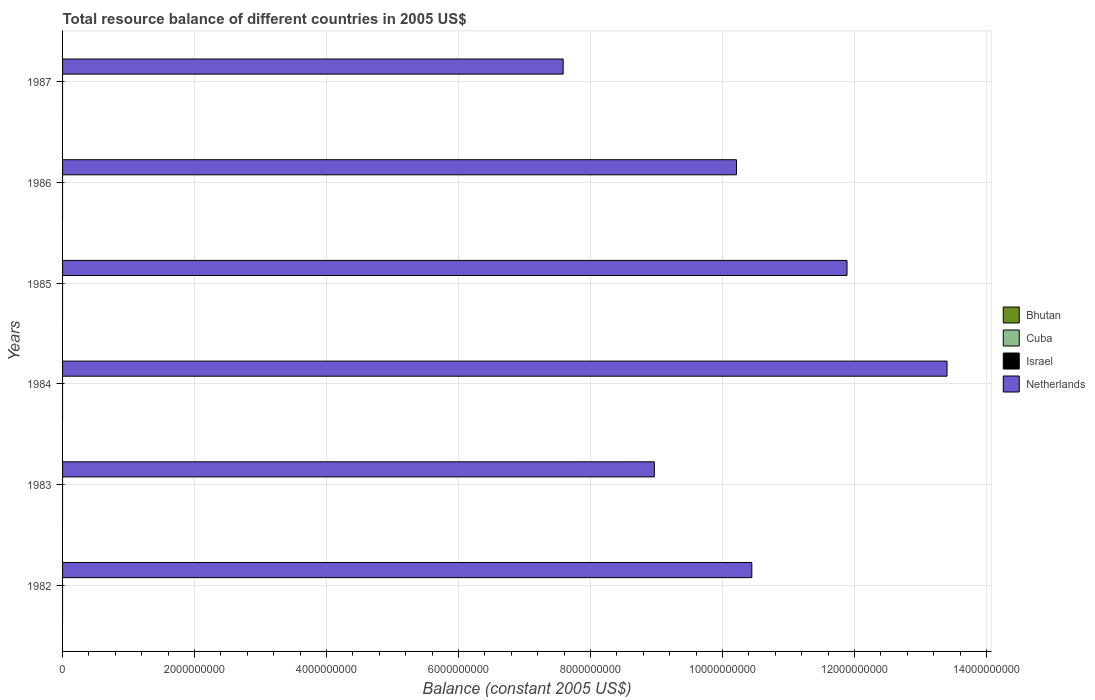Are the number of bars on each tick of the Y-axis equal?
Your answer should be very brief. Yes. What is the label of the 5th group of bars from the top?
Offer a terse response. 1983. In how many cases, is the number of bars for a given year not equal to the number of legend labels?
Your response must be concise. 6. What is the total resource balance in Cuba in 1985?
Your answer should be very brief. 0. Across all years, what is the maximum total resource balance in Netherlands?
Your answer should be very brief. 1.34e+1. Across all years, what is the minimum total resource balance in Israel?
Keep it short and to the point. 0. What is the total total resource balance in Cuba in the graph?
Your answer should be compact. 0. What is the difference between the total resource balance in Netherlands in 1983 and that in 1984?
Ensure brevity in your answer.  -4.44e+09. What is the difference between the total resource balance in Netherlands in 1984 and the total resource balance in Cuba in 1986?
Your response must be concise. 1.34e+1. What is the ratio of the total resource balance in Netherlands in 1984 to that in 1987?
Offer a very short reply. 1.77. Is the total resource balance in Netherlands in 1984 less than that in 1987?
Your answer should be very brief. No. What is the difference between the highest and the second highest total resource balance in Netherlands?
Make the answer very short. 1.52e+09. What is the difference between the highest and the lowest total resource balance in Netherlands?
Ensure brevity in your answer.  5.82e+09. Is it the case that in every year, the sum of the total resource balance in Bhutan and total resource balance in Cuba is greater than the total resource balance in Israel?
Make the answer very short. No. How many bars are there?
Your answer should be compact. 6. Does the graph contain any zero values?
Offer a terse response. Yes. Does the graph contain grids?
Offer a terse response. Yes. How are the legend labels stacked?
Make the answer very short. Vertical. What is the title of the graph?
Ensure brevity in your answer.  Total resource balance of different countries in 2005 US$. Does "Other small states" appear as one of the legend labels in the graph?
Offer a terse response. No. What is the label or title of the X-axis?
Ensure brevity in your answer.  Balance (constant 2005 US$). What is the Balance (constant 2005 US$) in Israel in 1982?
Make the answer very short. 0. What is the Balance (constant 2005 US$) of Netherlands in 1982?
Your answer should be very brief. 1.04e+1. What is the Balance (constant 2005 US$) in Cuba in 1983?
Your answer should be compact. 0. What is the Balance (constant 2005 US$) in Israel in 1983?
Your answer should be very brief. 0. What is the Balance (constant 2005 US$) in Netherlands in 1983?
Your answer should be compact. 8.97e+09. What is the Balance (constant 2005 US$) of Israel in 1984?
Give a very brief answer. 0. What is the Balance (constant 2005 US$) of Netherlands in 1984?
Ensure brevity in your answer.  1.34e+1. What is the Balance (constant 2005 US$) in Bhutan in 1985?
Offer a terse response. 0. What is the Balance (constant 2005 US$) in Cuba in 1985?
Ensure brevity in your answer.  0. What is the Balance (constant 2005 US$) in Israel in 1985?
Give a very brief answer. 0. What is the Balance (constant 2005 US$) in Netherlands in 1985?
Offer a very short reply. 1.19e+1. What is the Balance (constant 2005 US$) in Cuba in 1986?
Keep it short and to the point. 0. What is the Balance (constant 2005 US$) in Netherlands in 1986?
Provide a short and direct response. 1.02e+1. What is the Balance (constant 2005 US$) of Bhutan in 1987?
Offer a terse response. 0. What is the Balance (constant 2005 US$) of Cuba in 1987?
Give a very brief answer. 0. What is the Balance (constant 2005 US$) of Netherlands in 1987?
Make the answer very short. 7.59e+09. Across all years, what is the maximum Balance (constant 2005 US$) of Netherlands?
Your response must be concise. 1.34e+1. Across all years, what is the minimum Balance (constant 2005 US$) in Netherlands?
Keep it short and to the point. 7.59e+09. What is the total Balance (constant 2005 US$) in Israel in the graph?
Provide a succinct answer. 0. What is the total Balance (constant 2005 US$) of Netherlands in the graph?
Your response must be concise. 6.25e+1. What is the difference between the Balance (constant 2005 US$) in Netherlands in 1982 and that in 1983?
Provide a short and direct response. 1.48e+09. What is the difference between the Balance (constant 2005 US$) in Netherlands in 1982 and that in 1984?
Keep it short and to the point. -2.96e+09. What is the difference between the Balance (constant 2005 US$) of Netherlands in 1982 and that in 1985?
Ensure brevity in your answer.  -1.44e+09. What is the difference between the Balance (constant 2005 US$) in Netherlands in 1982 and that in 1986?
Offer a very short reply. 2.32e+08. What is the difference between the Balance (constant 2005 US$) of Netherlands in 1982 and that in 1987?
Give a very brief answer. 2.86e+09. What is the difference between the Balance (constant 2005 US$) of Netherlands in 1983 and that in 1984?
Offer a very short reply. -4.44e+09. What is the difference between the Balance (constant 2005 US$) in Netherlands in 1983 and that in 1985?
Offer a very short reply. -2.92e+09. What is the difference between the Balance (constant 2005 US$) of Netherlands in 1983 and that in 1986?
Provide a succinct answer. -1.24e+09. What is the difference between the Balance (constant 2005 US$) in Netherlands in 1983 and that in 1987?
Provide a short and direct response. 1.38e+09. What is the difference between the Balance (constant 2005 US$) in Netherlands in 1984 and that in 1985?
Offer a terse response. 1.52e+09. What is the difference between the Balance (constant 2005 US$) of Netherlands in 1984 and that in 1986?
Give a very brief answer. 3.19e+09. What is the difference between the Balance (constant 2005 US$) of Netherlands in 1984 and that in 1987?
Make the answer very short. 5.82e+09. What is the difference between the Balance (constant 2005 US$) in Netherlands in 1985 and that in 1986?
Provide a succinct answer. 1.68e+09. What is the difference between the Balance (constant 2005 US$) in Netherlands in 1985 and that in 1987?
Keep it short and to the point. 4.30e+09. What is the difference between the Balance (constant 2005 US$) in Netherlands in 1986 and that in 1987?
Offer a terse response. 2.63e+09. What is the average Balance (constant 2005 US$) in Bhutan per year?
Provide a short and direct response. 0. What is the average Balance (constant 2005 US$) in Netherlands per year?
Make the answer very short. 1.04e+1. What is the ratio of the Balance (constant 2005 US$) of Netherlands in 1982 to that in 1983?
Give a very brief answer. 1.16. What is the ratio of the Balance (constant 2005 US$) in Netherlands in 1982 to that in 1984?
Offer a terse response. 0.78. What is the ratio of the Balance (constant 2005 US$) in Netherlands in 1982 to that in 1985?
Your answer should be compact. 0.88. What is the ratio of the Balance (constant 2005 US$) of Netherlands in 1982 to that in 1986?
Ensure brevity in your answer.  1.02. What is the ratio of the Balance (constant 2005 US$) in Netherlands in 1982 to that in 1987?
Provide a succinct answer. 1.38. What is the ratio of the Balance (constant 2005 US$) in Netherlands in 1983 to that in 1984?
Your answer should be very brief. 0.67. What is the ratio of the Balance (constant 2005 US$) in Netherlands in 1983 to that in 1985?
Your answer should be very brief. 0.75. What is the ratio of the Balance (constant 2005 US$) of Netherlands in 1983 to that in 1986?
Offer a terse response. 0.88. What is the ratio of the Balance (constant 2005 US$) of Netherlands in 1983 to that in 1987?
Your answer should be compact. 1.18. What is the ratio of the Balance (constant 2005 US$) of Netherlands in 1984 to that in 1985?
Keep it short and to the point. 1.13. What is the ratio of the Balance (constant 2005 US$) in Netherlands in 1984 to that in 1986?
Offer a very short reply. 1.31. What is the ratio of the Balance (constant 2005 US$) in Netherlands in 1984 to that in 1987?
Give a very brief answer. 1.77. What is the ratio of the Balance (constant 2005 US$) in Netherlands in 1985 to that in 1986?
Give a very brief answer. 1.16. What is the ratio of the Balance (constant 2005 US$) of Netherlands in 1985 to that in 1987?
Offer a terse response. 1.57. What is the ratio of the Balance (constant 2005 US$) of Netherlands in 1986 to that in 1987?
Offer a very short reply. 1.35. What is the difference between the highest and the second highest Balance (constant 2005 US$) of Netherlands?
Ensure brevity in your answer.  1.52e+09. What is the difference between the highest and the lowest Balance (constant 2005 US$) of Netherlands?
Give a very brief answer. 5.82e+09. 